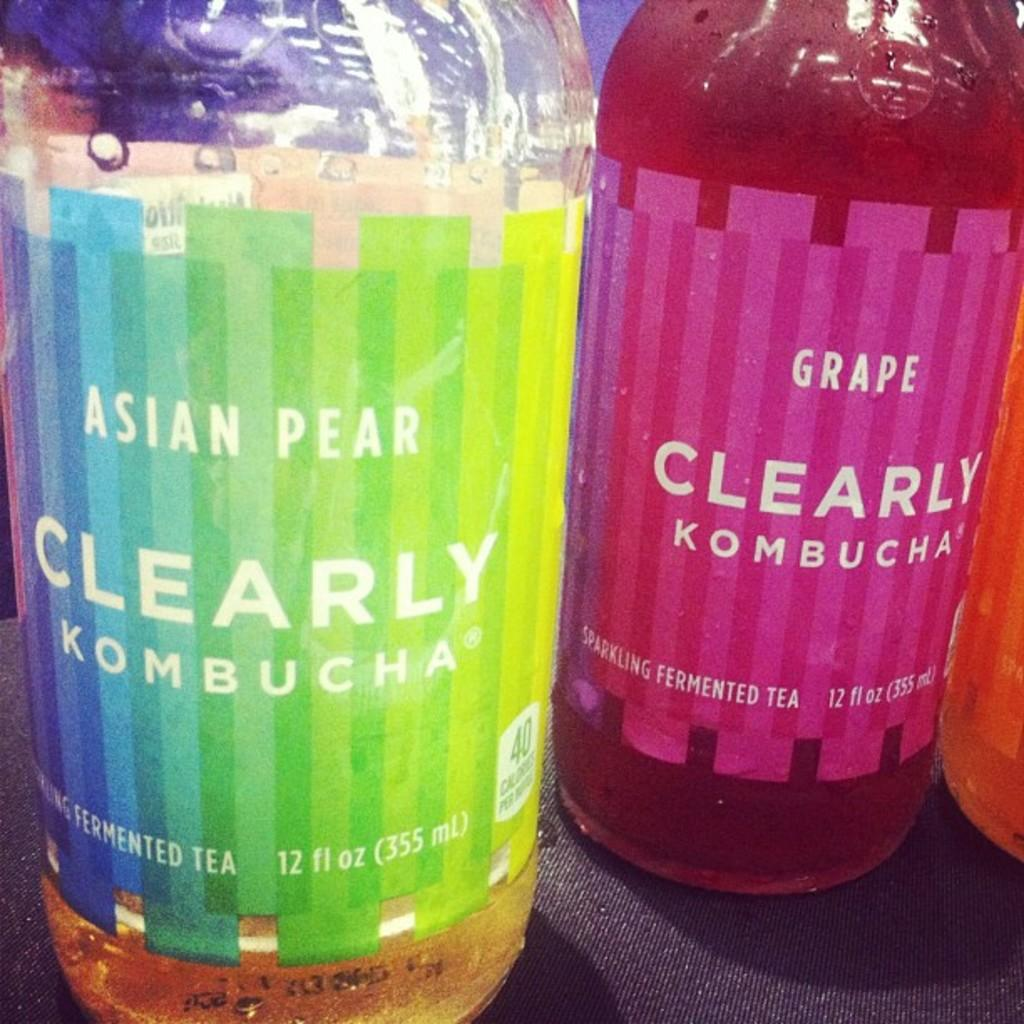<image>
Render a clear and concise summary of the photo. Rainbow colored label on a bottle for Clearly Kombucha. 